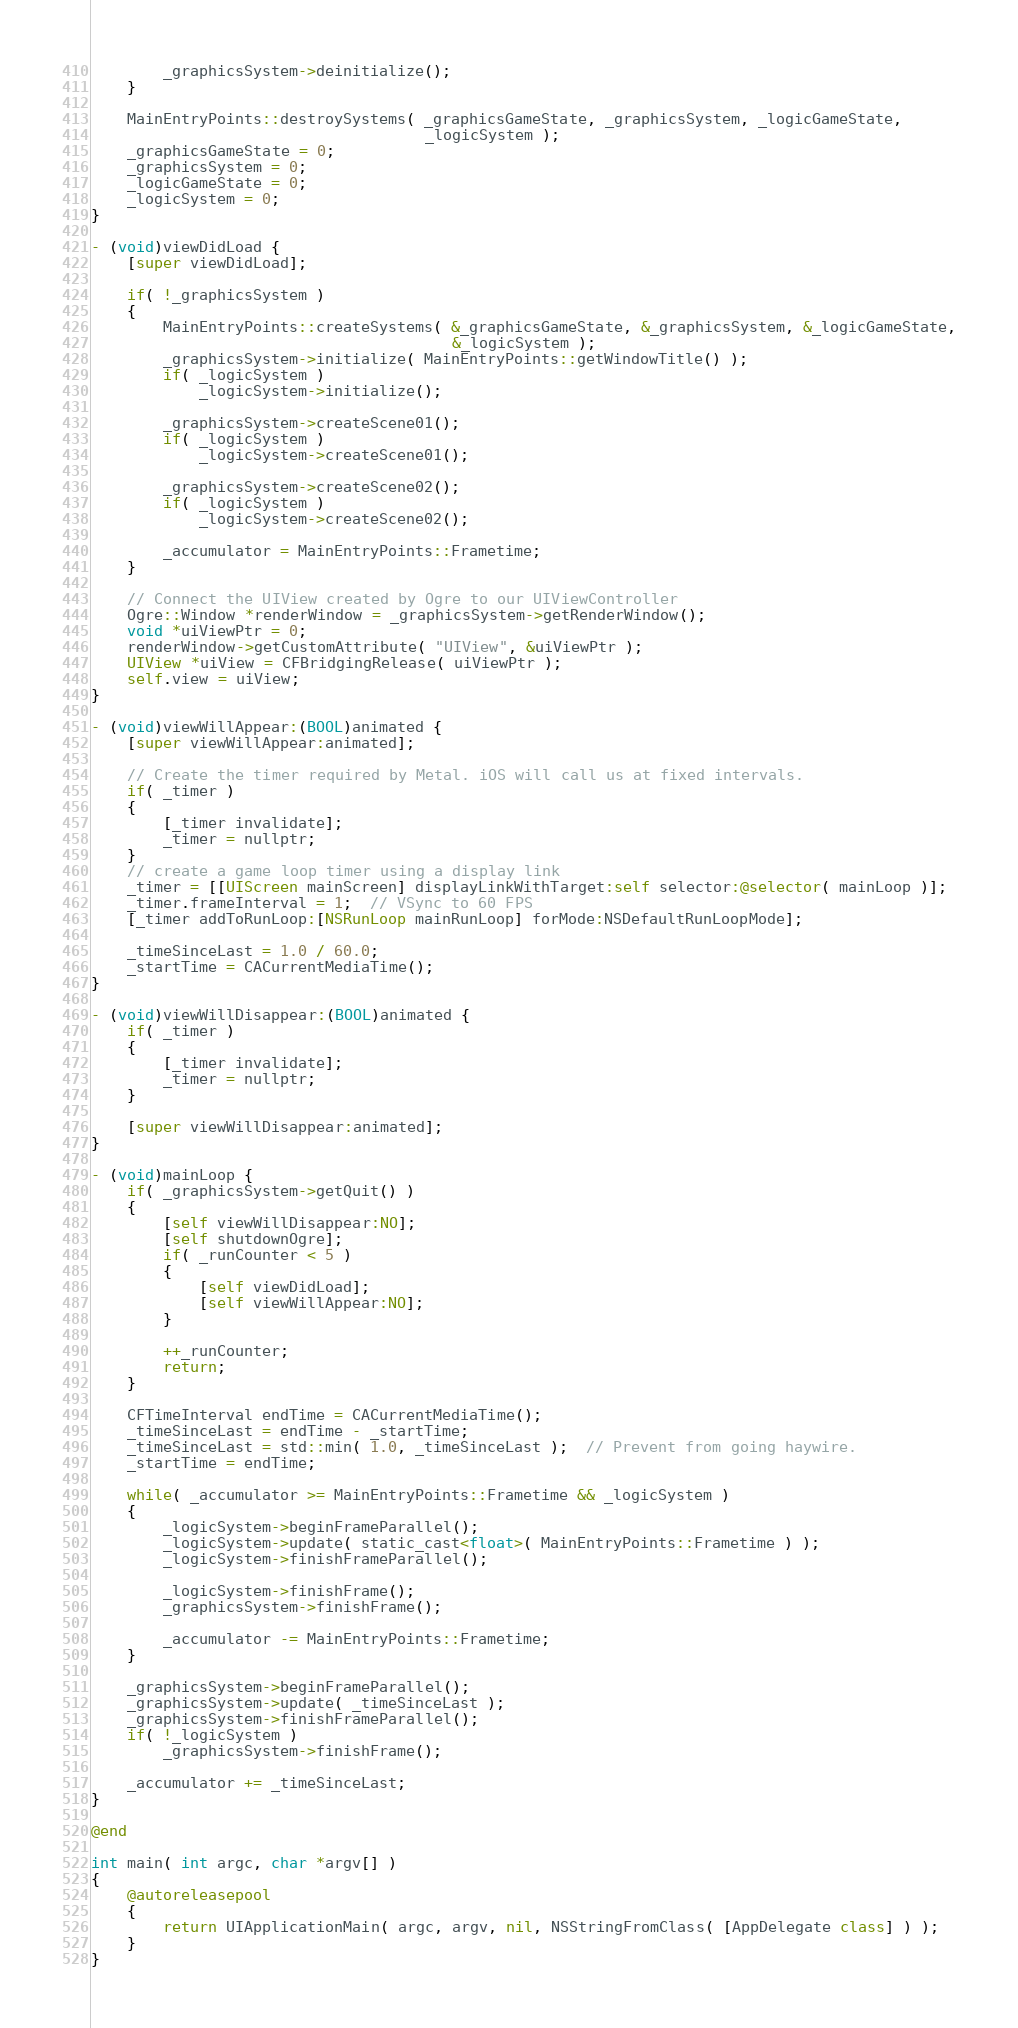Convert code to text. <code><loc_0><loc_0><loc_500><loc_500><_ObjectiveC_>        _graphicsSystem->deinitialize();
    }

    MainEntryPoints::destroySystems( _graphicsGameState, _graphicsSystem, _logicGameState,
                                     _logicSystem );
    _graphicsGameState = 0;
    _graphicsSystem = 0;
    _logicGameState = 0;
    _logicSystem = 0;
}

- (void)viewDidLoad {
    [super viewDidLoad];

    if( !_graphicsSystem )
    {
        MainEntryPoints::createSystems( &_graphicsGameState, &_graphicsSystem, &_logicGameState,
                                        &_logicSystem );
        _graphicsSystem->initialize( MainEntryPoints::getWindowTitle() );
        if( _logicSystem )
            _logicSystem->initialize();

        _graphicsSystem->createScene01();
        if( _logicSystem )
            _logicSystem->createScene01();

        _graphicsSystem->createScene02();
        if( _logicSystem )
            _logicSystem->createScene02();

        _accumulator = MainEntryPoints::Frametime;
    }

    // Connect the UIView created by Ogre to our UIViewController
    Ogre::Window *renderWindow = _graphicsSystem->getRenderWindow();
    void *uiViewPtr = 0;
    renderWindow->getCustomAttribute( "UIView", &uiViewPtr );
    UIView *uiView = CFBridgingRelease( uiViewPtr );
    self.view = uiView;
}

- (void)viewWillAppear:(BOOL)animated {
    [super viewWillAppear:animated];

    // Create the timer required by Metal. iOS will call us at fixed intervals.
    if( _timer )
    {
        [_timer invalidate];
        _timer = nullptr;
    }
    // create a game loop timer using a display link
    _timer = [[UIScreen mainScreen] displayLinkWithTarget:self selector:@selector( mainLoop )];
    _timer.frameInterval = 1;  // VSync to 60 FPS
    [_timer addToRunLoop:[NSRunLoop mainRunLoop] forMode:NSDefaultRunLoopMode];

    _timeSinceLast = 1.0 / 60.0;
    _startTime = CACurrentMediaTime();
}

- (void)viewWillDisappear:(BOOL)animated {
    if( _timer )
    {
        [_timer invalidate];
        _timer = nullptr;
    }

    [super viewWillDisappear:animated];
}

- (void)mainLoop {
    if( _graphicsSystem->getQuit() )
    {
        [self viewWillDisappear:NO];
        [self shutdownOgre];
        if( _runCounter < 5 )
        {
            [self viewDidLoad];
            [self viewWillAppear:NO];
        }

        ++_runCounter;
        return;
    }

    CFTimeInterval endTime = CACurrentMediaTime();
    _timeSinceLast = endTime - _startTime;
    _timeSinceLast = std::min( 1.0, _timeSinceLast );  // Prevent from going haywire.
    _startTime = endTime;

    while( _accumulator >= MainEntryPoints::Frametime && _logicSystem )
    {
        _logicSystem->beginFrameParallel();
        _logicSystem->update( static_cast<float>( MainEntryPoints::Frametime ) );
        _logicSystem->finishFrameParallel();

        _logicSystem->finishFrame();
        _graphicsSystem->finishFrame();

        _accumulator -= MainEntryPoints::Frametime;
    }

    _graphicsSystem->beginFrameParallel();
    _graphicsSystem->update( _timeSinceLast );
    _graphicsSystem->finishFrameParallel();
    if( !_logicSystem )
        _graphicsSystem->finishFrame();

    _accumulator += _timeSinceLast;
}

@end

int main( int argc, char *argv[] )
{
    @autoreleasepool
    {
        return UIApplicationMain( argc, argv, nil, NSStringFromClass( [AppDelegate class] ) );
    }
}
</code> 